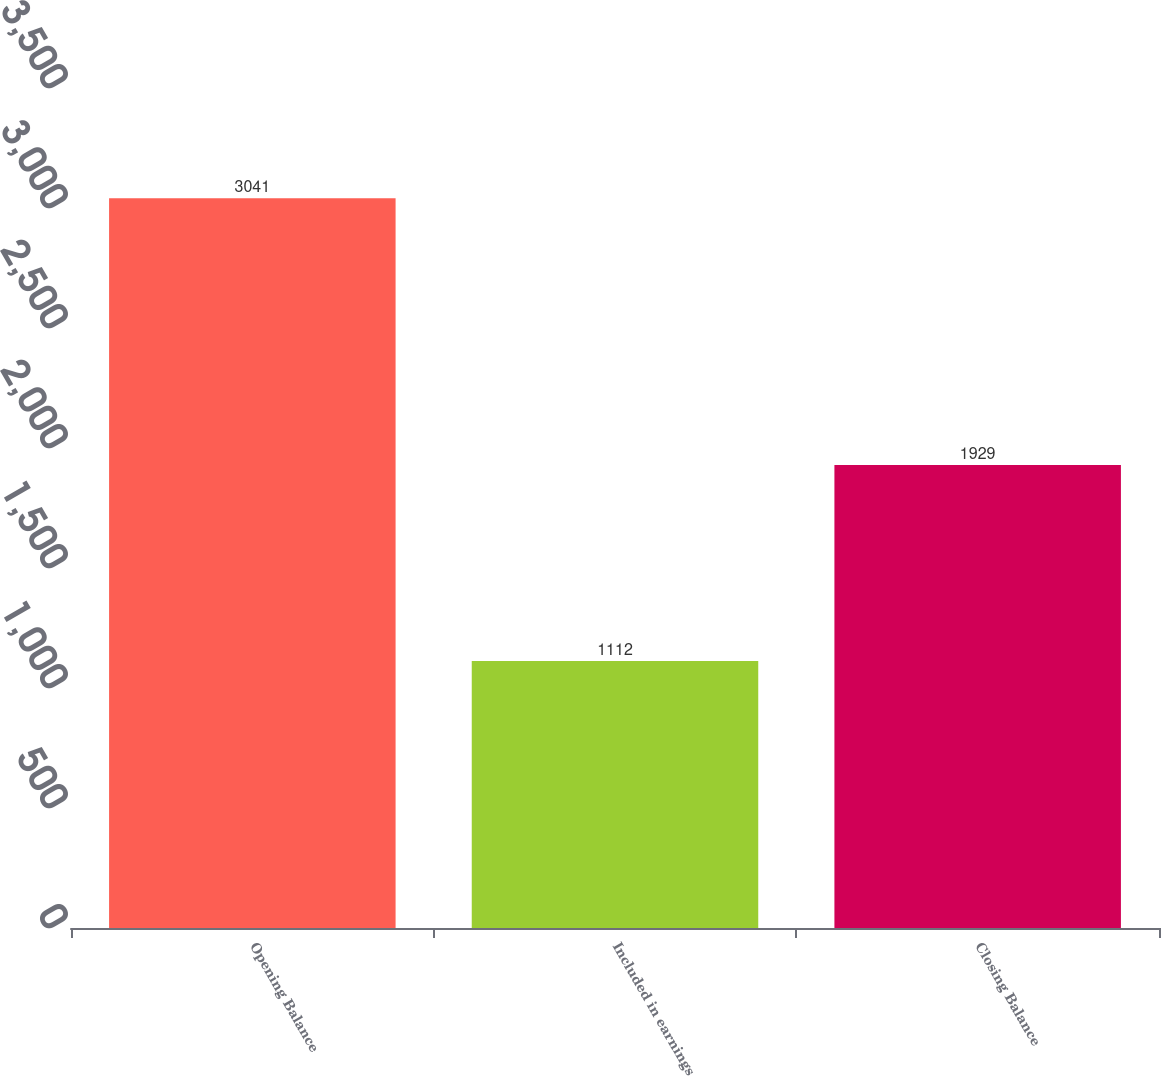Convert chart to OTSL. <chart><loc_0><loc_0><loc_500><loc_500><bar_chart><fcel>Opening Balance<fcel>Included in earnings<fcel>Closing Balance<nl><fcel>3041<fcel>1112<fcel>1929<nl></chart> 